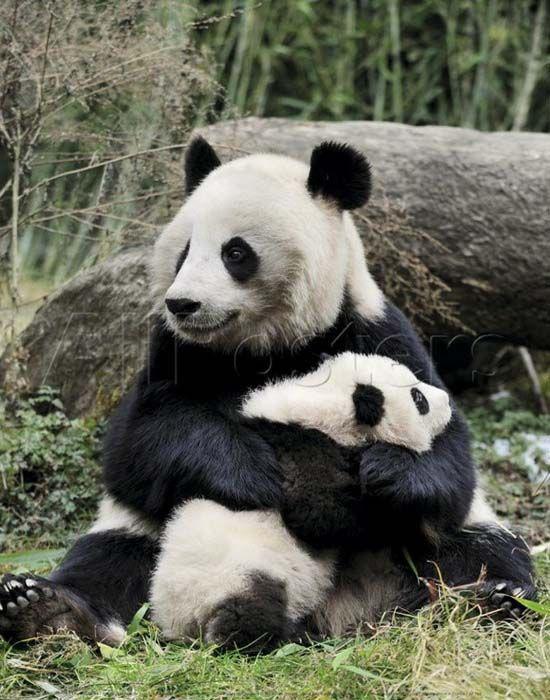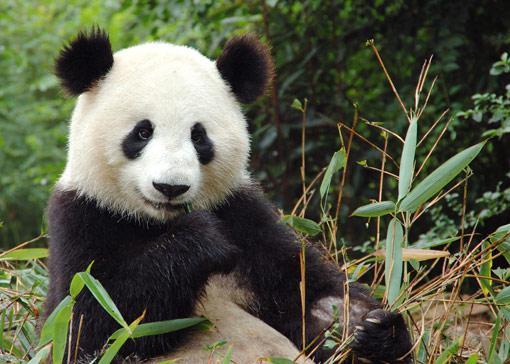The first image is the image on the left, the second image is the image on the right. Evaluate the accuracy of this statement regarding the images: "There are four pandas.". Is it true? Answer yes or no. No. The first image is the image on the left, the second image is the image on the right. For the images displayed, is the sentence "There are four pandas." factually correct? Answer yes or no. No. 